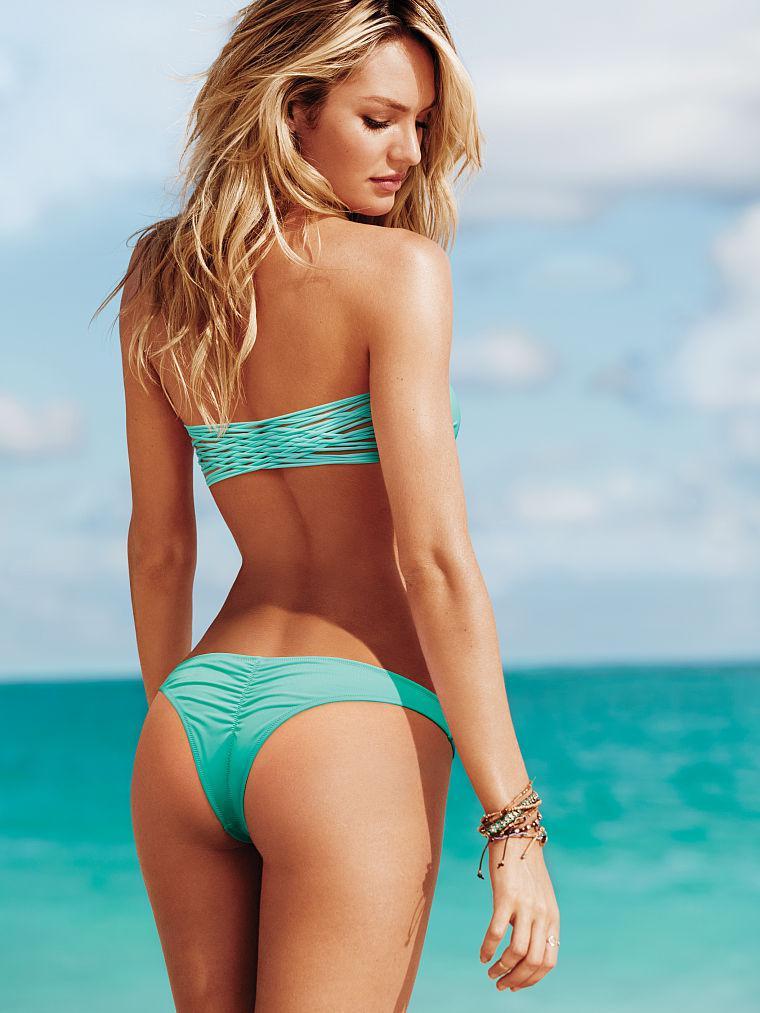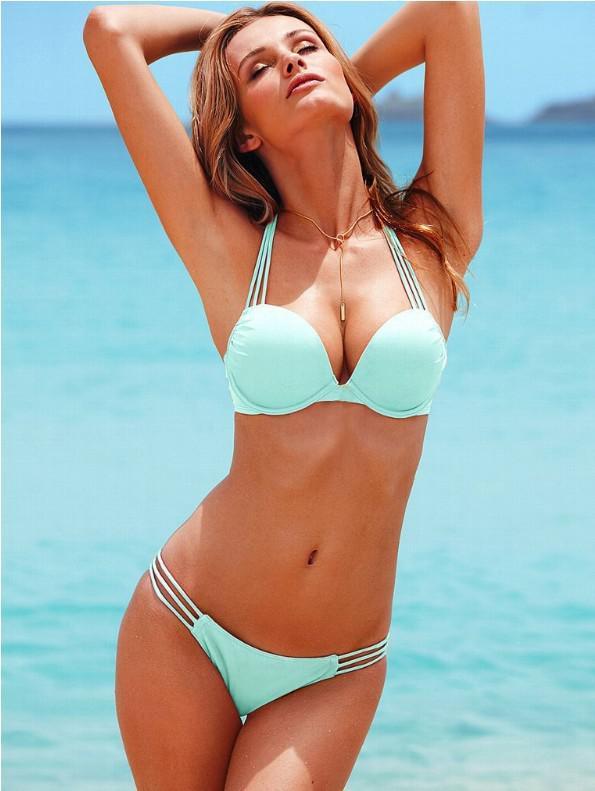The first image is the image on the left, the second image is the image on the right. Considering the images on both sides, is "The left and right image contains the same number of women in bikinis with at least one in all white." valid? Answer yes or no. No. 